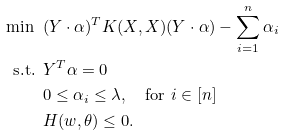<formula> <loc_0><loc_0><loc_500><loc_500>\min \ & ( Y \cdot \alpha ) ^ { T } K ( X , X ) ( Y \cdot \alpha ) - \sum _ { i = 1 } ^ { n } \alpha _ { i } \\ \text {s.t. } & Y ^ { T } \alpha = 0 \\ & 0 \leq \alpha _ { i } \leq \lambda , \quad \text {for } i \in [ n ] \\ & H ( w , \theta ) \leq 0 .</formula> 